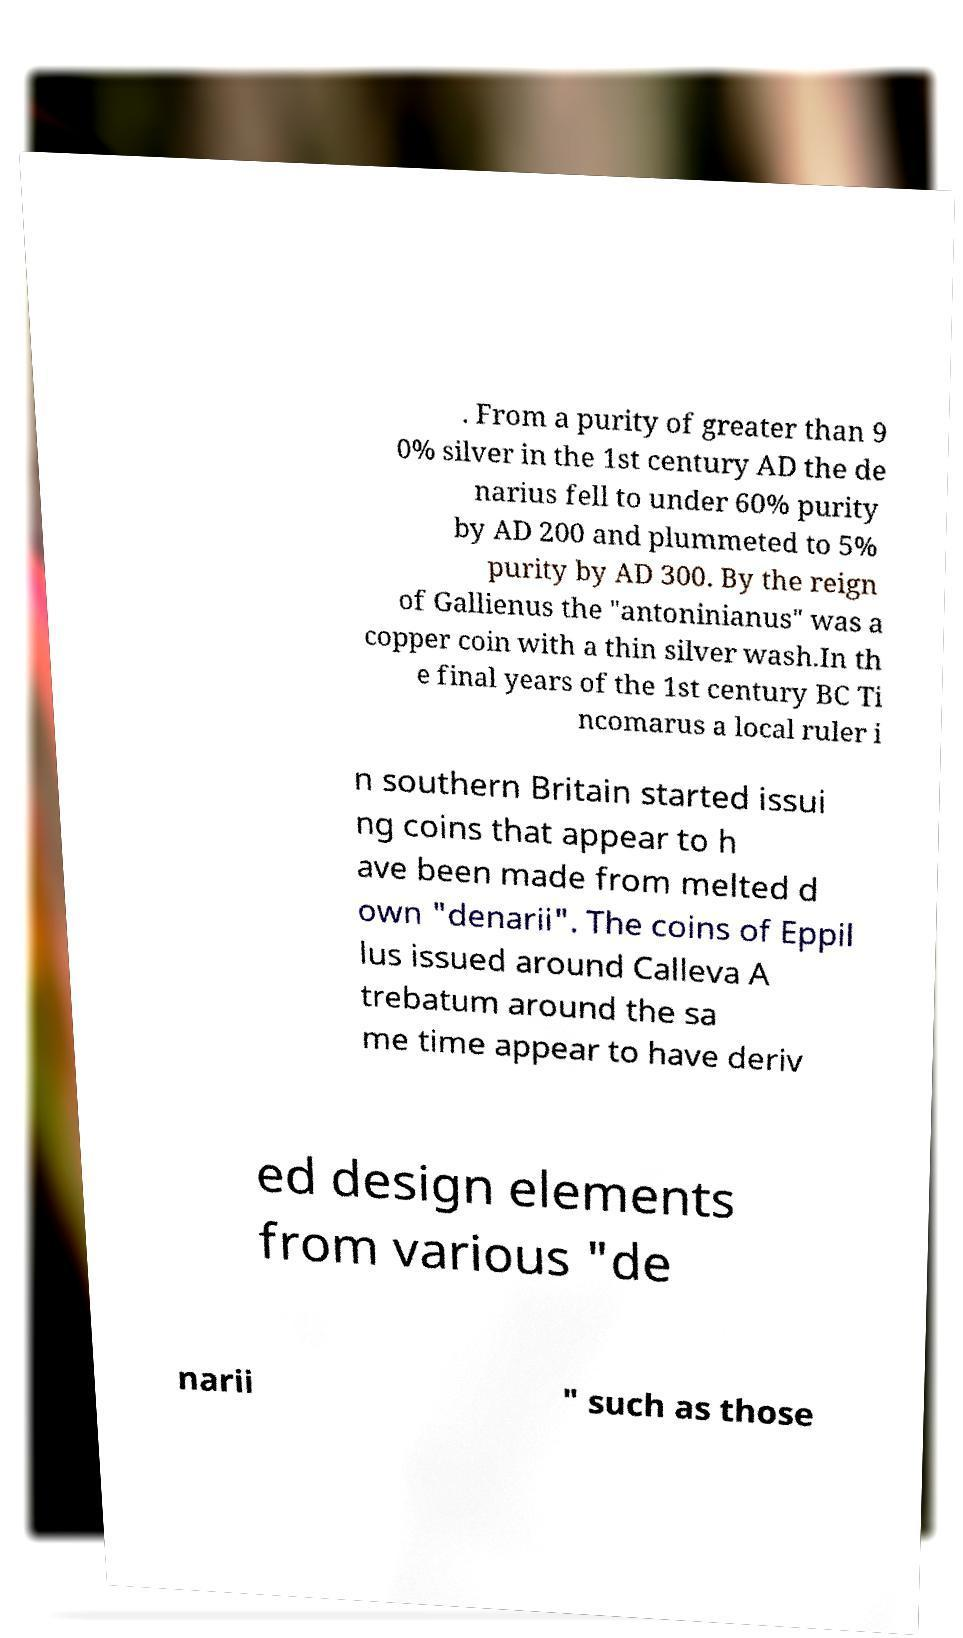Can you accurately transcribe the text from the provided image for me? . From a purity of greater than 9 0% silver in the 1st century AD the de narius fell to under 60% purity by AD 200 and plummeted to 5% purity by AD 300. By the reign of Gallienus the "antoninianus" was a copper coin with a thin silver wash.In th e final years of the 1st century BC Ti ncomarus a local ruler i n southern Britain started issui ng coins that appear to h ave been made from melted d own "denarii". The coins of Eppil lus issued around Calleva A trebatum around the sa me time appear to have deriv ed design elements from various "de narii " such as those 